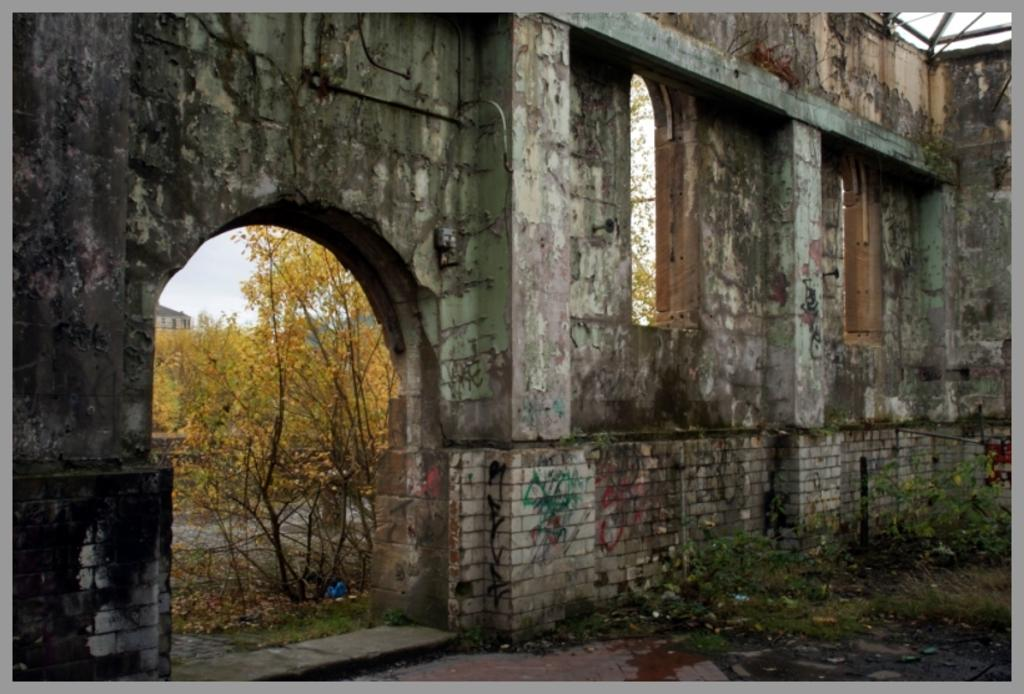What type of structure can be seen in the image? There is an arch in the image. What else can be seen in the image besides the arch? There is a wall, plants, trees, a building, and dried leaves on the ground in the image. What is the background of the image? The sky is visible in the background of the image. What type of curve can be seen in the cemetery in the image? There is no cemetery present in the image, and therefore no curve can be observed in that context. 